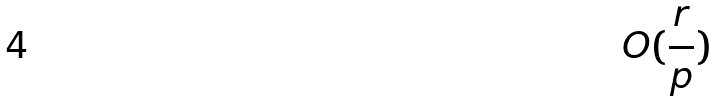<formula> <loc_0><loc_0><loc_500><loc_500>O ( \frac { r } { p } )</formula> 